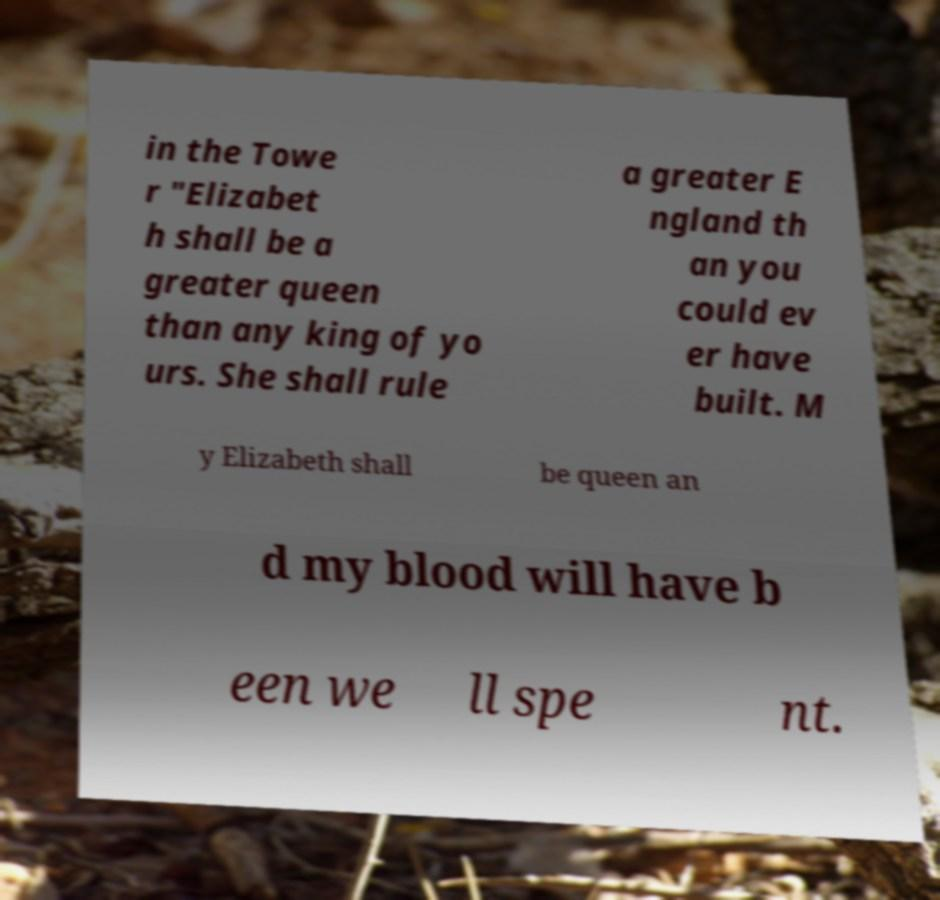Could you extract and type out the text from this image? in the Towe r "Elizabet h shall be a greater queen than any king of yo urs. She shall rule a greater E ngland th an you could ev er have built. M y Elizabeth shall be queen an d my blood will have b een we ll spe nt. 